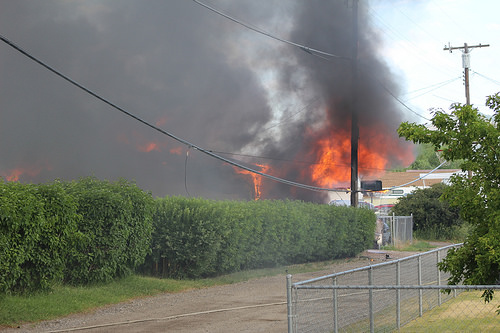<image>
Is there a fire behind the plant? Yes. From this viewpoint, the fire is positioned behind the plant, with the plant partially or fully occluding the fire. 